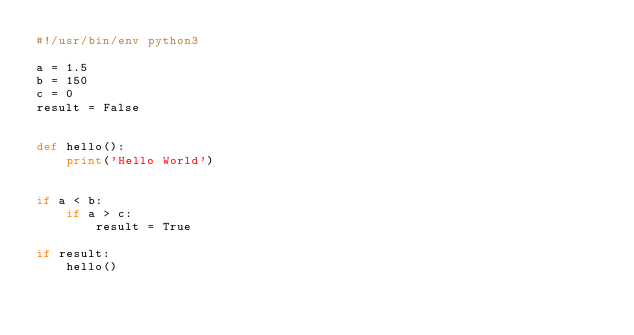<code> <loc_0><loc_0><loc_500><loc_500><_Python_>#!/usr/bin/env python3

a = 1.5
b = 150
c = 0
result = False


def hello():
    print('Hello World')


if a < b:
    if a > c:
        result = True

if result:
    hello()
</code> 